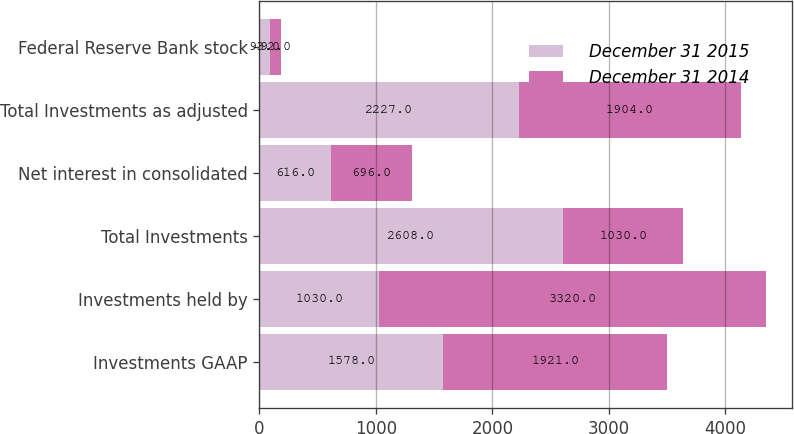Convert chart to OTSL. <chart><loc_0><loc_0><loc_500><loc_500><stacked_bar_chart><ecel><fcel>Investments GAAP<fcel>Investments held by<fcel>Total Investments<fcel>Net interest in consolidated<fcel>Total Investments as adjusted<fcel>Federal Reserve Bank stock<nl><fcel>December 31 2015<fcel>1578<fcel>1030<fcel>2608<fcel>616<fcel>2227<fcel>93<nl><fcel>December 31 2014<fcel>1921<fcel>3320<fcel>1030<fcel>696<fcel>1904<fcel>92<nl></chart> 